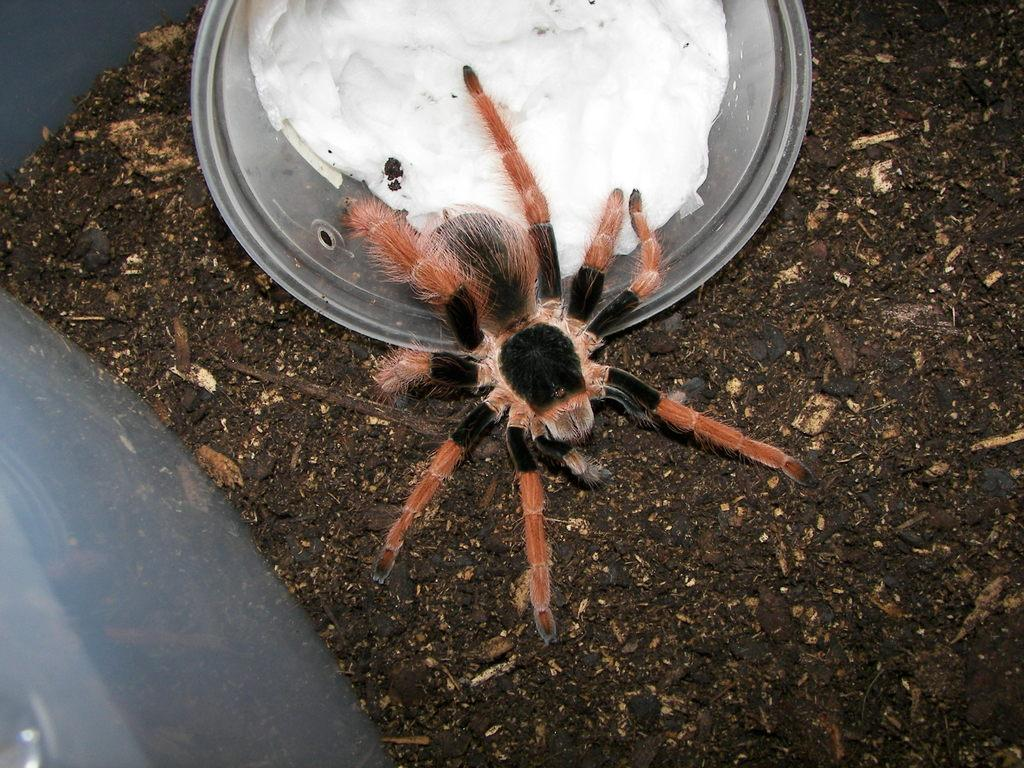What is located in the image? There is a bowl and a spider on the ground in the image. What is inside the bowl? There is food inside the bowl. How many tomatoes are on the railway in the image? There are no tomatoes or railway present in the image. 